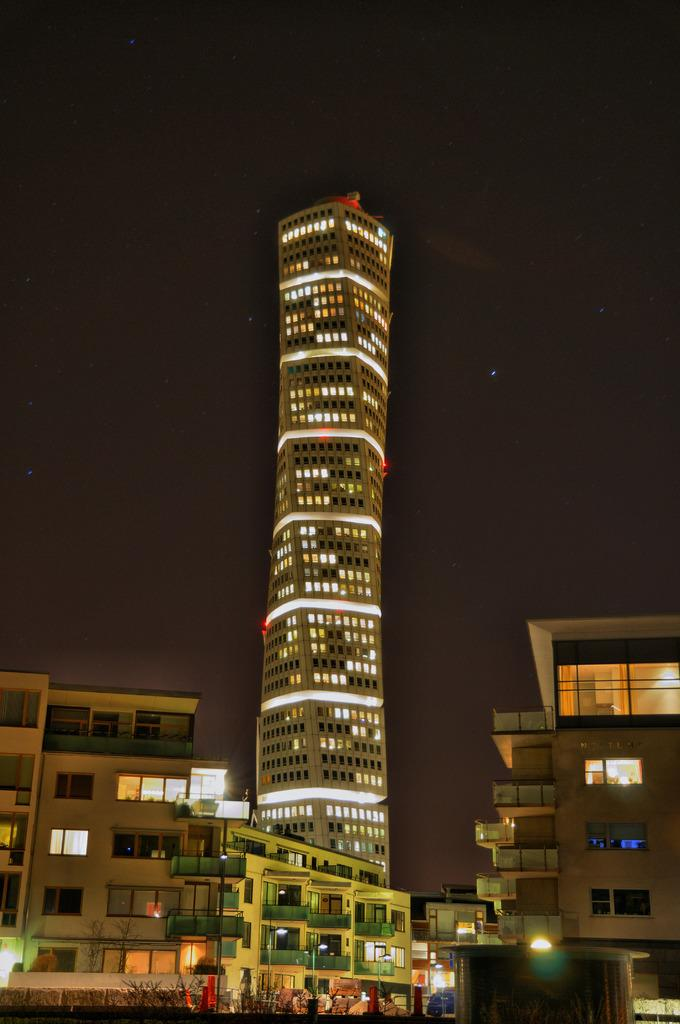What type of structures can be seen in the image? There are buildings in the image, including a tower building. What feature of the buildings is visible in the image? The windows of the building are visible. Are there any other objects or features in the image besides the buildings? Yes, there are lights in the image. What can be seen in the background of the image? The sky is visible in the image. What type of calculator is being used by the train in the image? There is no calculator or train present in the image; it features buildings and their windows. 